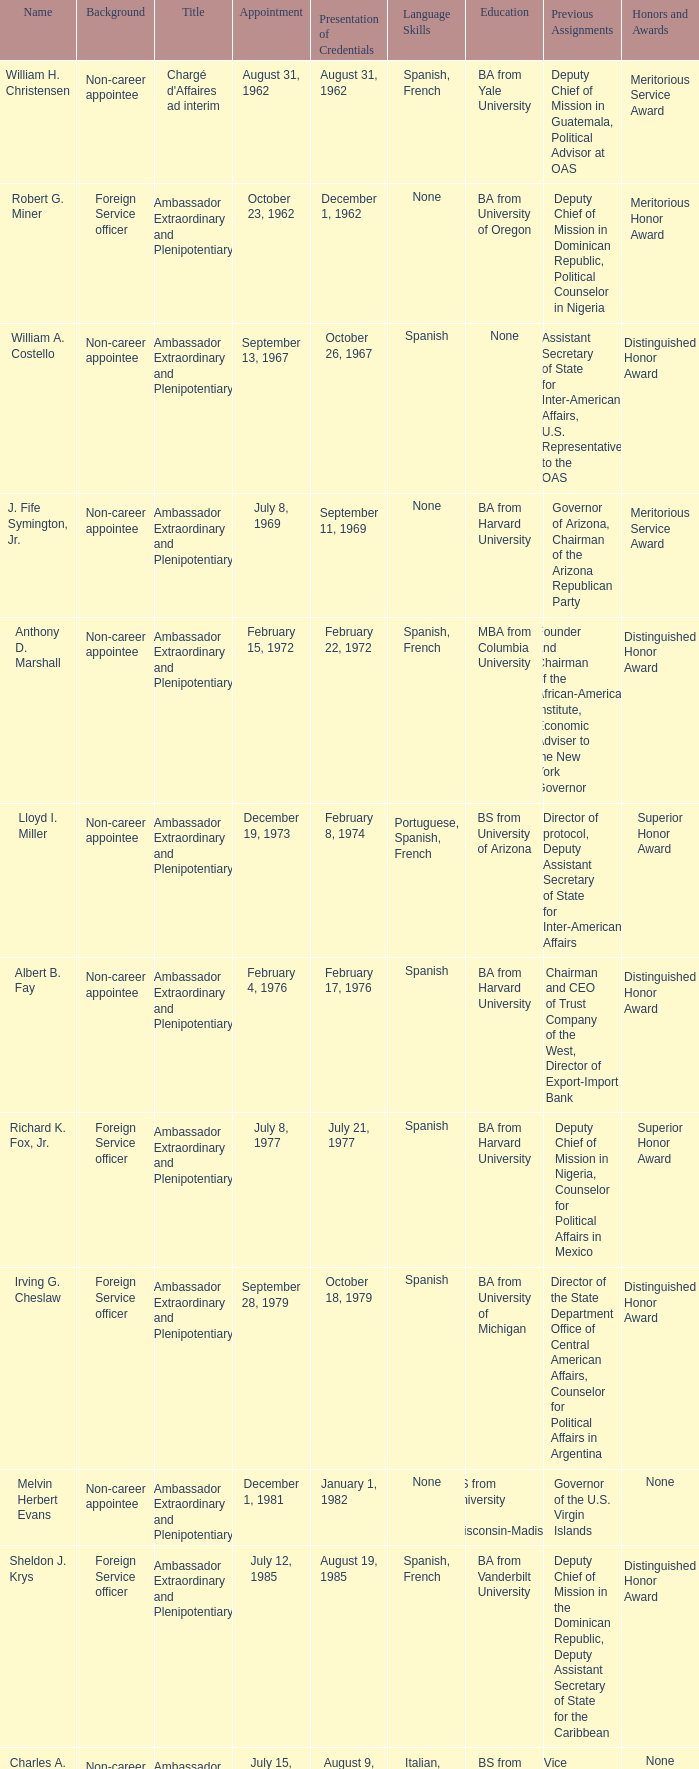What was Anthony D. Marshall's title? Ambassador Extraordinary and Plenipotentiary. 